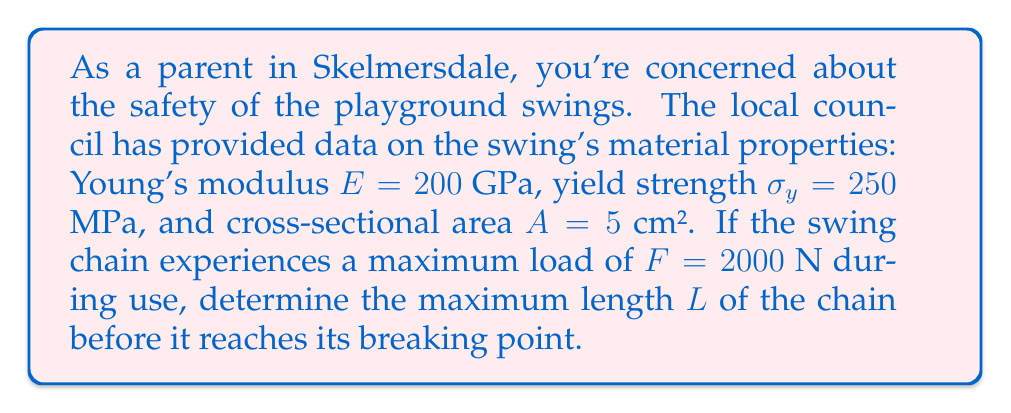Show me your answer to this math problem. To solve this problem, we'll use stress-strain analysis:

1) First, calculate the stress $\sigma$ on the chain:
   $$\sigma = \frac{F}{A} = \frac{2000 \text{ N}}{5 \times 10^{-4} \text{ m}^2} = 4 \times 10^6 \text{ Pa} = 4 \text{ MPa}$$

2) The chain will break when the stress reaches the yield strength. We can use Hooke's Law to relate stress and strain:
   $$\sigma = E \varepsilon$$
   where $\varepsilon$ is the strain.

3) At the breaking point, $\sigma = \sigma_y$, so:
   $$250 \times 10^6 \text{ Pa} = 200 \times 10^9 \text{ Pa} \times \varepsilon$$

4) Solve for $\varepsilon$:
   $$\varepsilon = \frac{250 \times 10^6}{200 \times 10^9} = 0.00125 = 0.125\%$$

5) Strain is defined as the change in length over the original length:
   $$\varepsilon = \frac{\Delta L}{L}$$

6) We want to find $L$ when $\Delta L$ is the difference between the length at yield strength and the length under normal load:
   $$0.00125 = \frac{L_y - L}{L}$$
   where $L_y$ is the length at yield strength and $L$ is the original length.

7) Rearrange to solve for $L$:
   $$L = \frac{L_y}{1.00125}$$

8) To find $L_y$, use Hooke's Law in terms of force and displacement:
   $$F = k\Delta L$$
   where $k = \frac{EA}{L}$ is the spring constant.

9) At yield:
   $$250 \times 10^6 \text{ Pa} \times 5 \times 10^{-4} \text{ m}^2 = \frac{200 \times 10^9 \text{ Pa} \times 5 \times 10^{-4} \text{ m}^2}{L_y} \times (L_y - L)$$

10) Simplify and solve for $L_y$:
    $$L_y = 1.00125L$$

11) Substitute this back into the equation from step 7:
    $$L = \frac{1.00125L}{1.00125} = L$$

This means the chain will break when it reaches its yield strength, regardless of its initial length.
Answer: The chain will break when it reaches its yield strength, regardless of its initial length. 